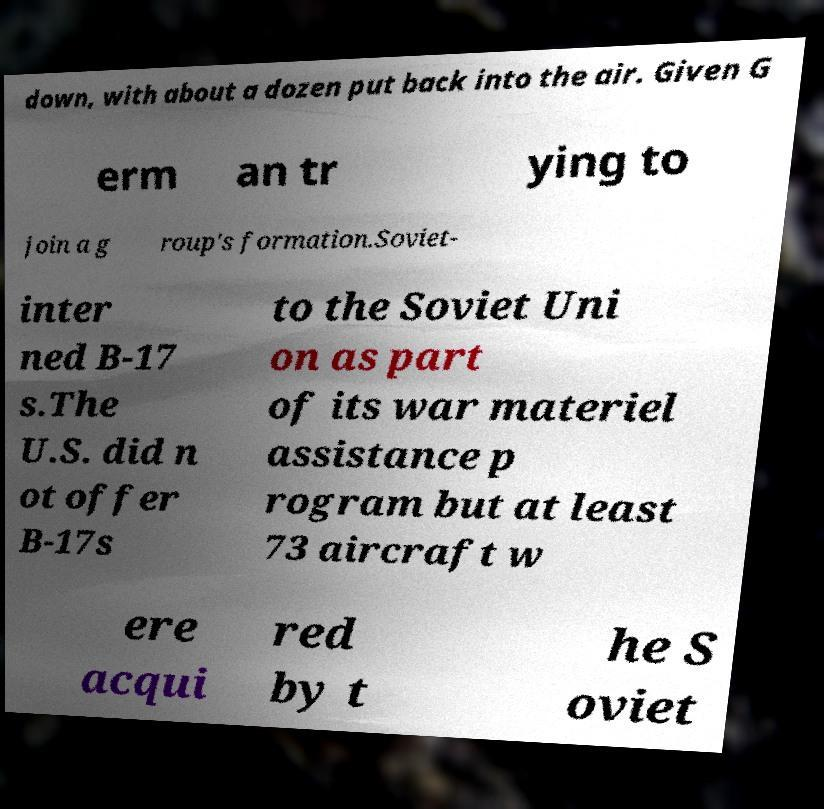Can you accurately transcribe the text from the provided image for me? down, with about a dozen put back into the air. Given G erm an tr ying to join a g roup's formation.Soviet- inter ned B-17 s.The U.S. did n ot offer B-17s to the Soviet Uni on as part of its war materiel assistance p rogram but at least 73 aircraft w ere acqui red by t he S oviet 